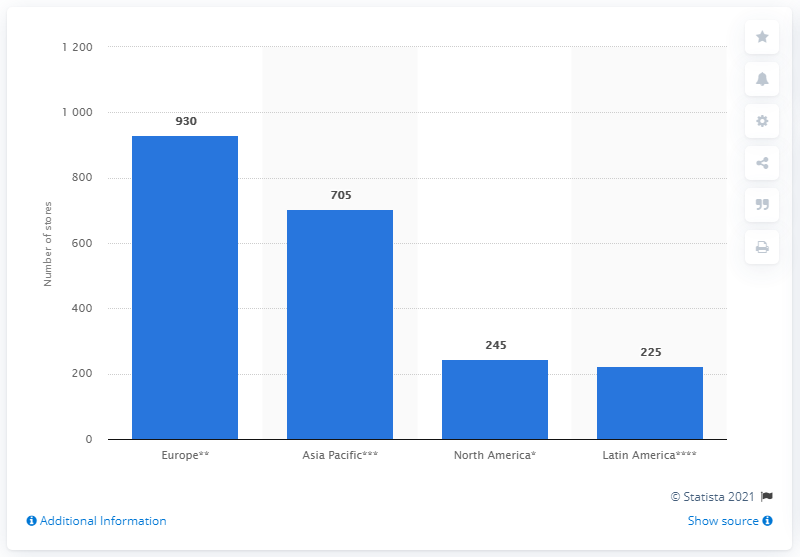List a handful of essential elements in this visual. The ranking of countries from the highest to lowest in terms of the number of Tommy Hilfiger stores worldwide is as follows: Europe, Asia Pacific, North America, Latin America. In 2018, PVH operated a total of 930 Tommy Hilfiger stores in Europe. The value of the leftmost bar is 930. 